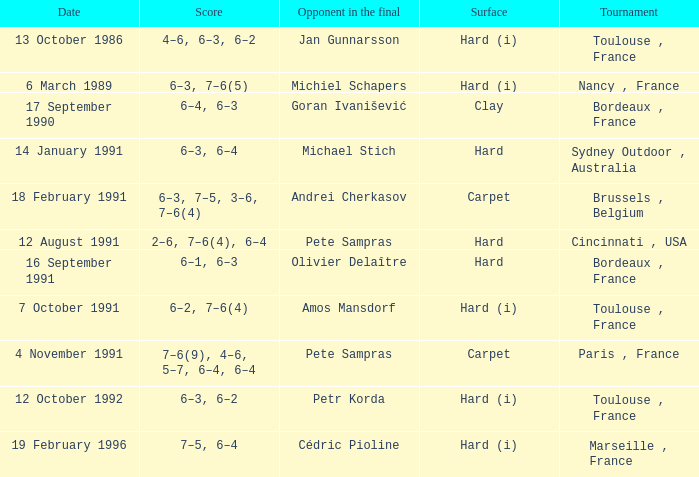What is the date of the tournament with olivier delaître as the opponent in the final? 16 September 1991. 